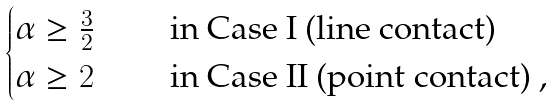<formula> <loc_0><loc_0><loc_500><loc_500>\begin{cases} \alpha \geq \frac { 3 } { 2 } & \quad \text { in Case I (line contact) } \\ \alpha \geq 2 & \quad \text { in Case II (point contact) } , \end{cases}</formula> 